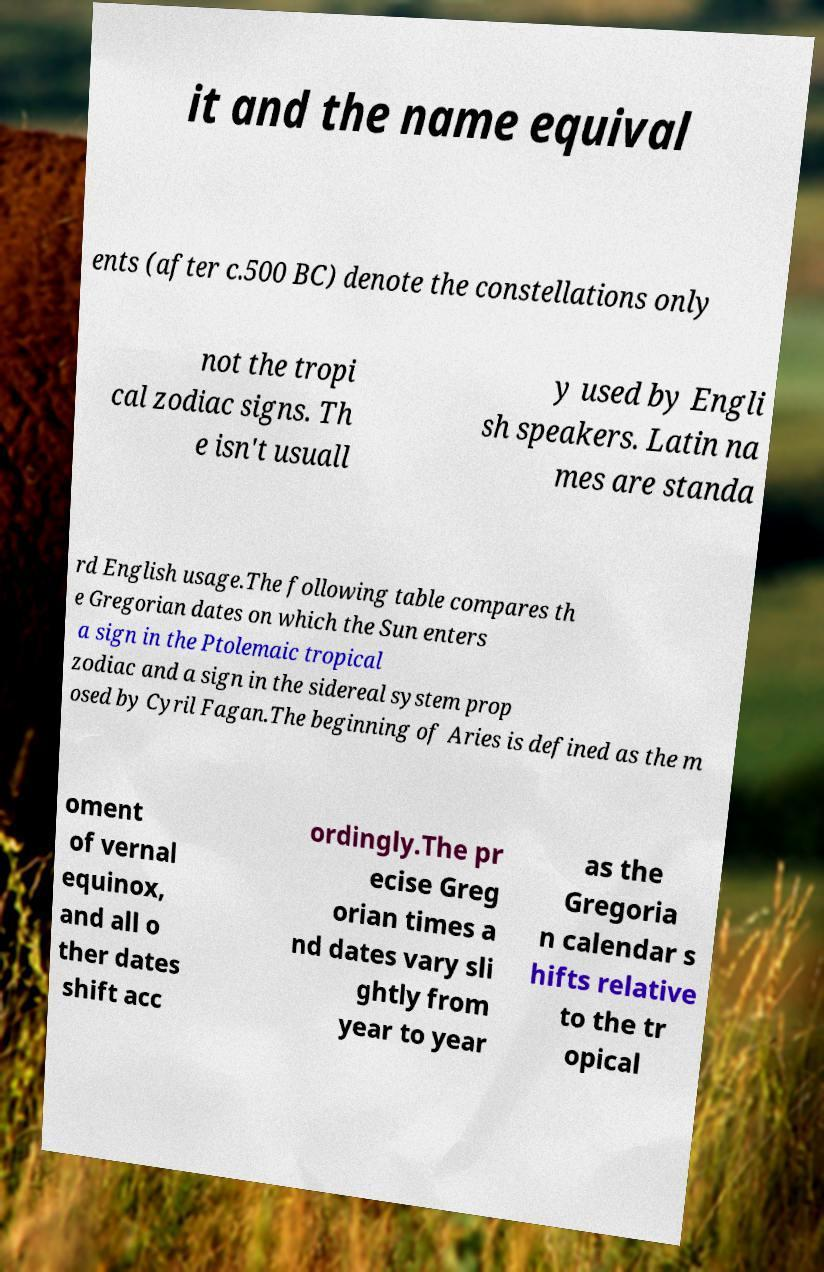Can you read and provide the text displayed in the image?This photo seems to have some interesting text. Can you extract and type it out for me? it and the name equival ents (after c.500 BC) denote the constellations only not the tropi cal zodiac signs. Th e isn't usuall y used by Engli sh speakers. Latin na mes are standa rd English usage.The following table compares th e Gregorian dates on which the Sun enters a sign in the Ptolemaic tropical zodiac and a sign in the sidereal system prop osed by Cyril Fagan.The beginning of Aries is defined as the m oment of vernal equinox, and all o ther dates shift acc ordingly.The pr ecise Greg orian times a nd dates vary sli ghtly from year to year as the Gregoria n calendar s hifts relative to the tr opical 